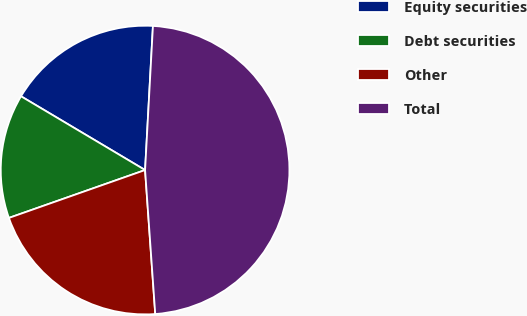<chart> <loc_0><loc_0><loc_500><loc_500><pie_chart><fcel>Equity securities<fcel>Debt securities<fcel>Other<fcel>Total<nl><fcel>17.33%<fcel>13.92%<fcel>20.74%<fcel>48.01%<nl></chart> 